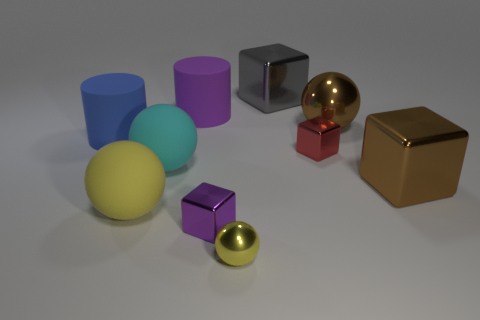Subtract all brown shiny balls. How many balls are left? 3 Subtract all purple cylinders. How many cylinders are left? 1 Subtract all cubes. How many objects are left? 6 Add 2 big brown blocks. How many big brown blocks are left? 3 Add 9 tiny brown shiny blocks. How many tiny brown shiny blocks exist? 9 Subtract 0 red spheres. How many objects are left? 10 Subtract 4 blocks. How many blocks are left? 0 Subtract all red cylinders. Subtract all green spheres. How many cylinders are left? 2 Subtract all yellow cylinders. How many gray cubes are left? 1 Subtract all large yellow rubber blocks. Subtract all purple cubes. How many objects are left? 9 